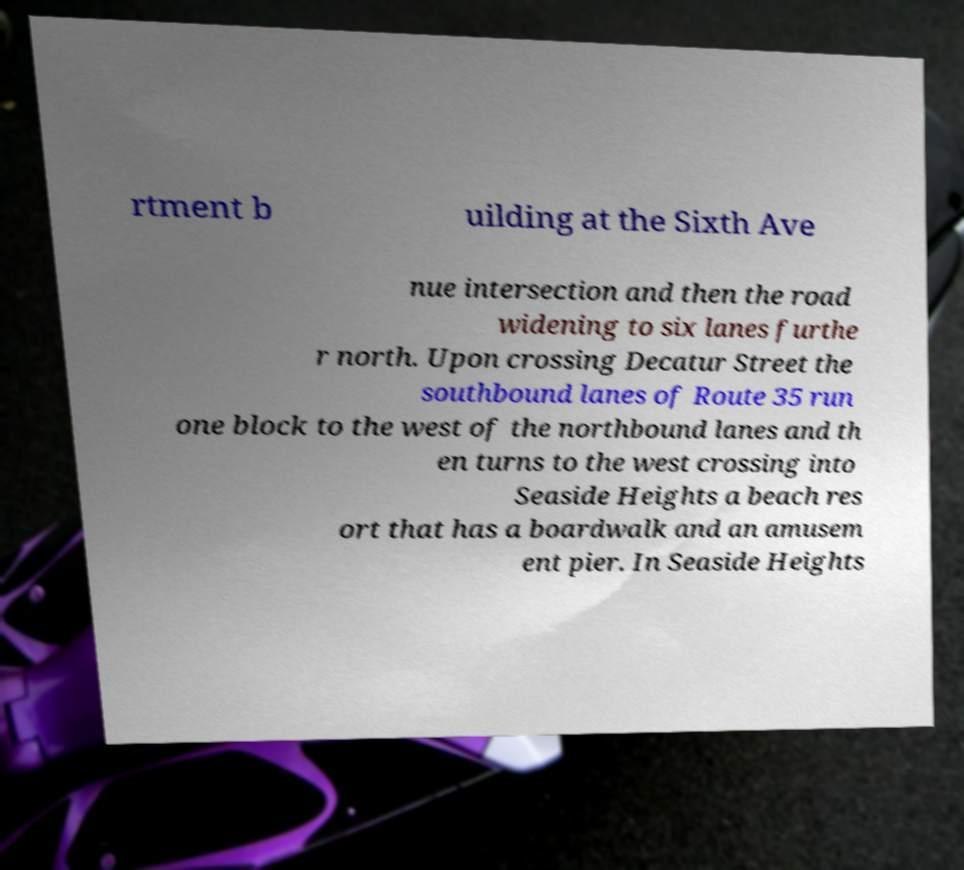Please read and relay the text visible in this image. What does it say? rtment b uilding at the Sixth Ave nue intersection and then the road widening to six lanes furthe r north. Upon crossing Decatur Street the southbound lanes of Route 35 run one block to the west of the northbound lanes and th en turns to the west crossing into Seaside Heights a beach res ort that has a boardwalk and an amusem ent pier. In Seaside Heights 